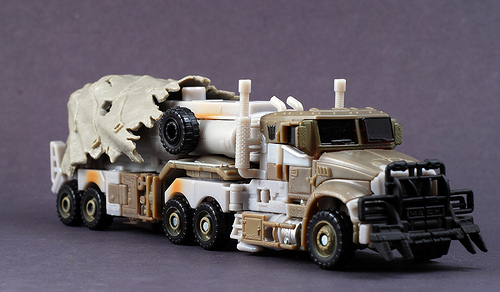<image>
Is the tire on the truck? Yes. Looking at the image, I can see the tire is positioned on top of the truck, with the truck providing support. 